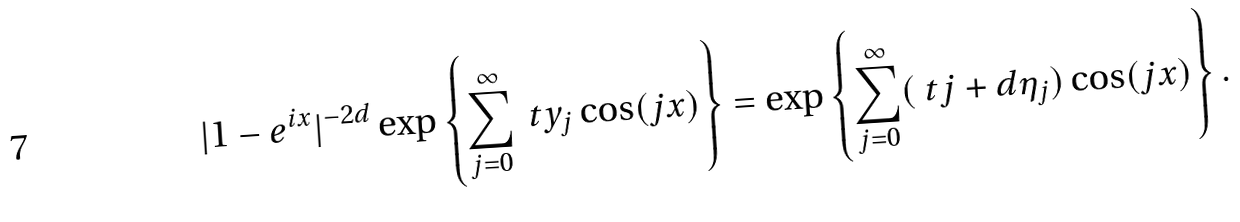Convert formula to latex. <formula><loc_0><loc_0><loc_500><loc_500>| 1 - e ^ { i x } | ^ { - 2 d } \exp \left \{ \sum _ { j = 0 } ^ { \infty } \ t y _ { j } \cos ( j x ) \right \} = \exp \left \{ \sum _ { j = 0 } ^ { \infty } ( \ t j + d \eta _ { j } ) \cos ( j x ) \right \} .</formula> 